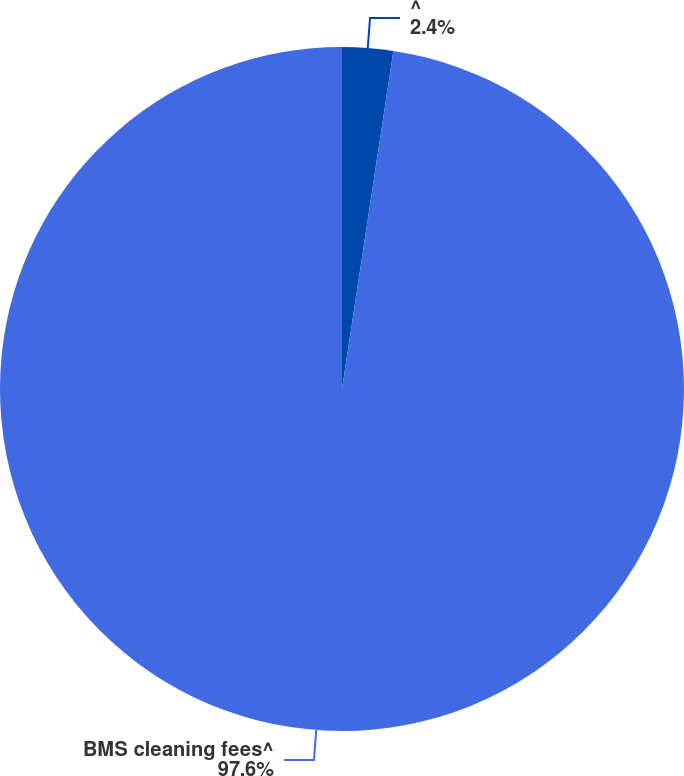Convert chart to OTSL. <chart><loc_0><loc_0><loc_500><loc_500><pie_chart><fcel>^<fcel>BMS cleaning fees^<nl><fcel>2.4%<fcel>97.6%<nl></chart> 